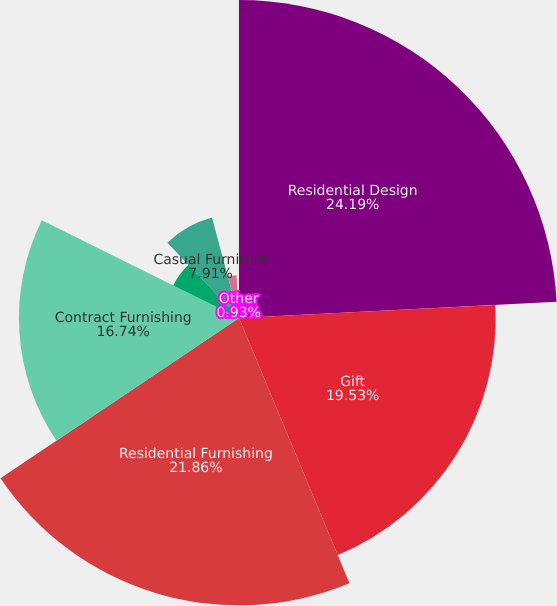Convert chart. <chart><loc_0><loc_0><loc_500><loc_500><pie_chart><fcel>Residential Design<fcel>Gift<fcel>Residential Furnishing<fcel>Contract Furnishing<fcel>Apparel<fcel>Casual Furniture<fcel>Building Products<fcel>Other<nl><fcel>24.19%<fcel>19.53%<fcel>21.86%<fcel>16.74%<fcel>5.58%<fcel>7.91%<fcel>3.26%<fcel>0.93%<nl></chart> 